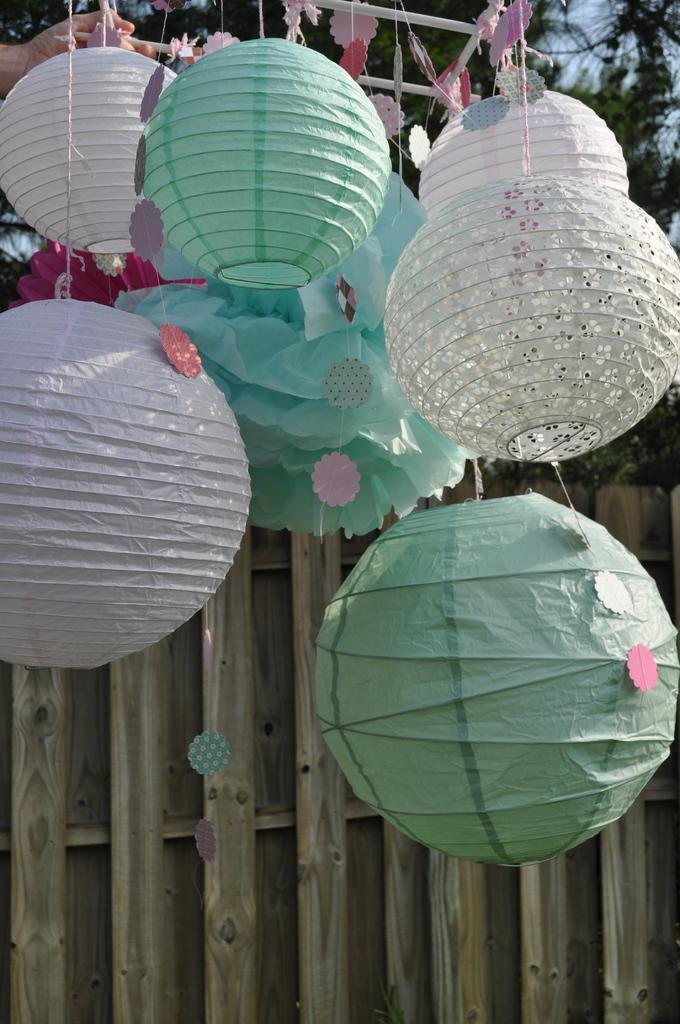In one or two sentences, can you explain what this image depicts? In this image there are paper lanterns hanging to a rod. At the bottom there is a wooden wall. At the top there are trees and the sky. 